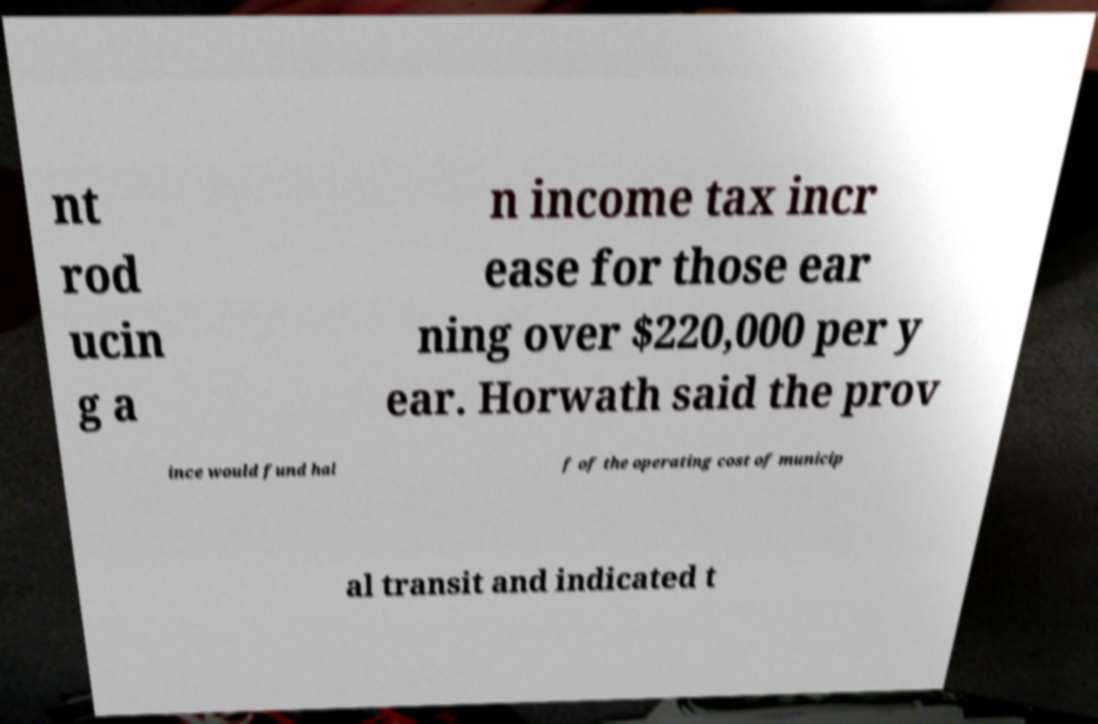Please read and relay the text visible in this image. What does it say? nt rod ucin g a n income tax incr ease for those ear ning over $220,000 per y ear. Horwath said the prov ince would fund hal f of the operating cost of municip al transit and indicated t 